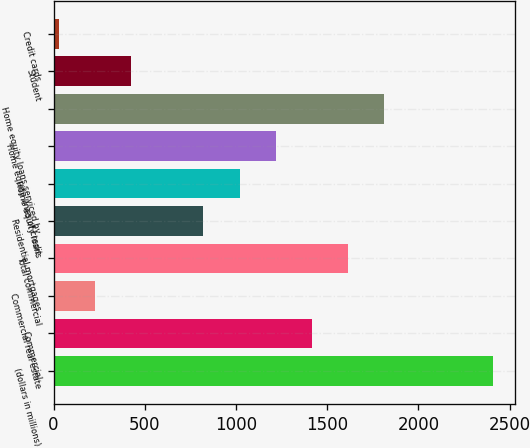Convert chart to OTSL. <chart><loc_0><loc_0><loc_500><loc_500><bar_chart><fcel>(dollars in millions)<fcel>Commercial<fcel>Commercial real estate<fcel>Total commercial<fcel>Residential mortgages<fcel>Home equity loans<fcel>Home equity lines of credit<fcel>Home equity loans serviced by<fcel>Student<fcel>Credit cards<nl><fcel>2407.4<fcel>1416.4<fcel>227.2<fcel>1614.6<fcel>821.8<fcel>1020<fcel>1218.2<fcel>1812.8<fcel>425.4<fcel>29<nl></chart> 